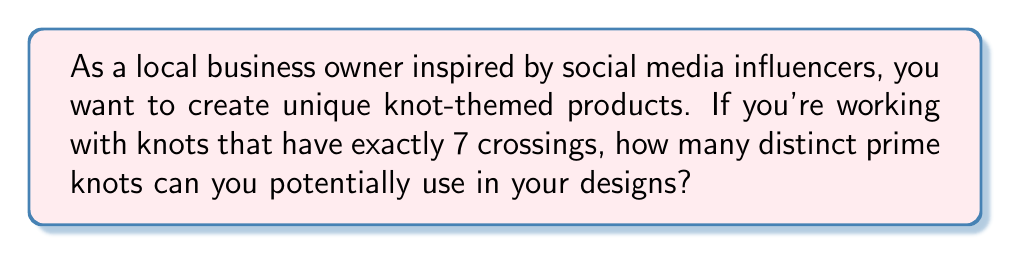Provide a solution to this math problem. To answer this question, we need to understand the concept of prime knots and the classification of knots based on their crossing number. Let's break it down step-by-step:

1. Prime knots: These are knots that cannot be decomposed into simpler knots. They are the fundamental building blocks in knot theory.

2. Crossing number: This is the minimum number of crossings that occur in any diagram of the knot.

3. Classification: Knots are classified based on their crossing number. For 7 crossings, we're looking at what are known as "7-crossing knots."

4. Tabulation: Mathematicians have tabulated prime knots up to certain crossing numbers. For 7-crossing knots, this work was completed in the late 19th century.

5. Count: According to knot tables, there are exactly 7 distinct prime knots with a crossing number of 7. These are often denoted as $7_1, 7_2, 7_3, 7_4, 7_5, 7_6,$ and $7_7$.

6. Verification: This count has been verified through various mathematical methods, including polynomial invariants and computer-aided calculations.

It's worth noting that while there are only 7 prime knots with exactly 7 crossings, there are many more knots that can be formed with 7 or fewer crossings when including composite knots (knots formed by combining prime knots).
Answer: 7 